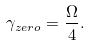Convert formula to latex. <formula><loc_0><loc_0><loc_500><loc_500>\gamma _ { z e r o } = \frac { \Omega } { 4 } .</formula> 